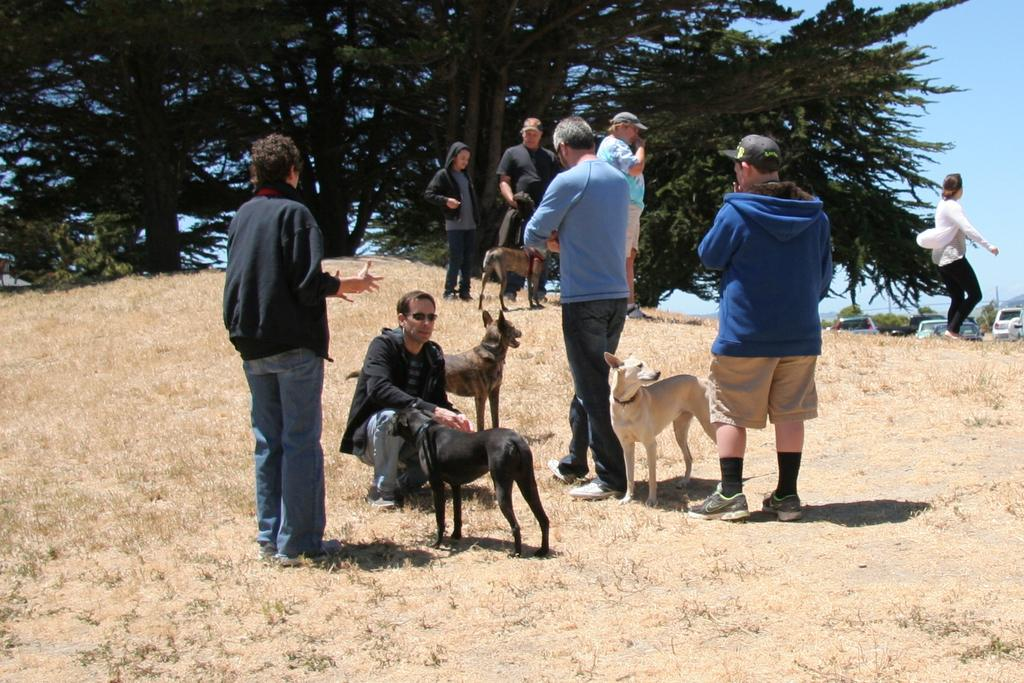Where was the image taken? The image was clicked outside. Who or what can be seen in the image? There is a group of people and dogs in the image. What is the woman in the right corner of the image doing? The woman is walking in the right corner of the image. What can be seen in the background of the image? There is a group of trees and trucks in the background of the image. Where is the volleyball court in the image? There is no volleyball court present in the image. Can you tell me how many blades are attached to the trucks in the background? There is no information about the trucks' blades in the image. 